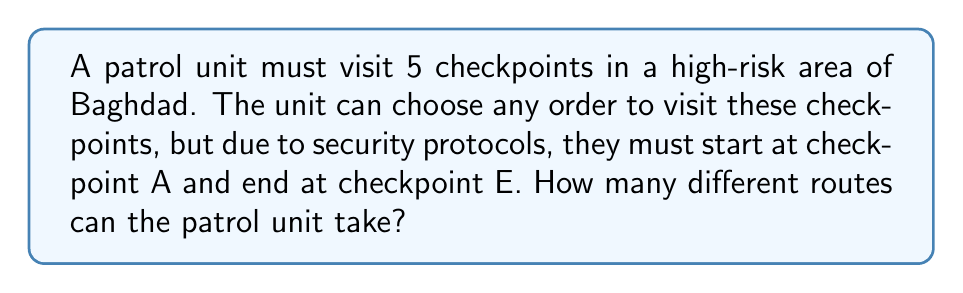Help me with this question. Let's approach this step-by-step:

1) We have 5 checkpoints in total: A, B, C, D, and E.

2) The patrol must start at A and end at E, so these positions are fixed.

3) This means we need to determine how many ways we can arrange the remaining 3 checkpoints (B, C, and D) between A and E.

4) This is a straightforward permutation problem. We have 3 elements to arrange, and the order matters.

5) The number of permutations of n distinct objects is given by the formula:

   $$P(n) = n!$$

   Where $n!$ represents the factorial of $n$.

6) In this case, $n = 3$, so we calculate:

   $$P(3) = 3! = 3 \times 2 \times 1 = 6$$

Therefore, there are 6 different ways to arrange the middle 3 checkpoints.

7) The complete routes would be:
   A-B-C-D-E
   A-B-D-C-E
   A-C-B-D-E
   A-C-D-B-E
   A-D-B-C-E
   A-D-C-B-E
Answer: The patrol unit can take 6 different routes. 